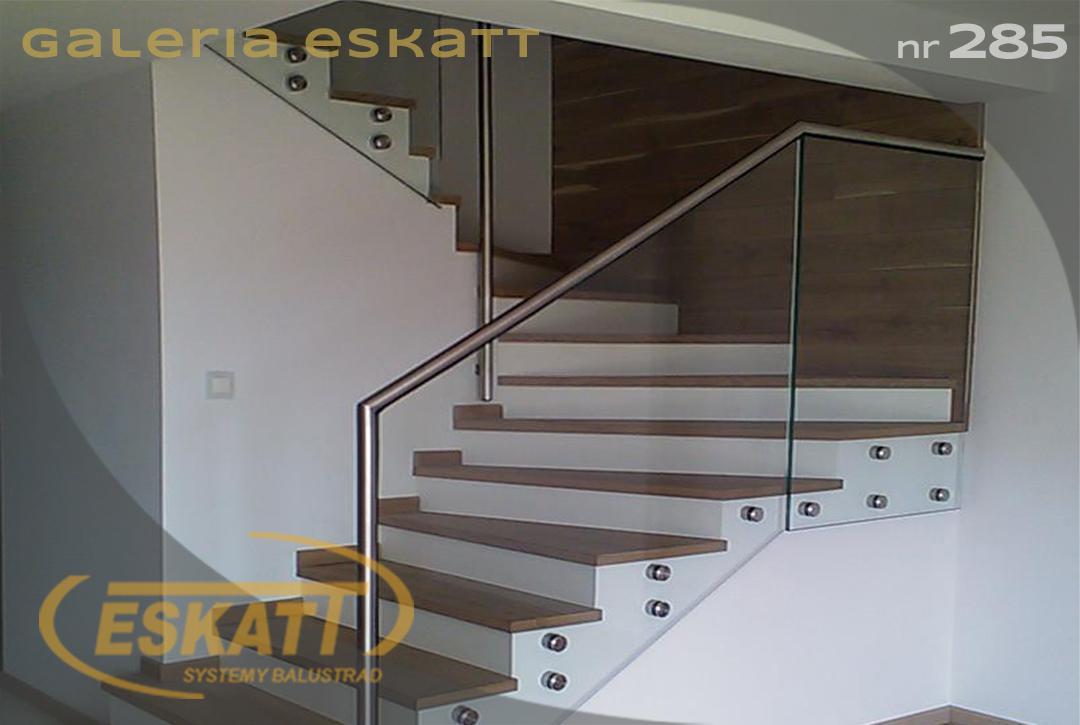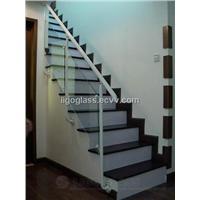The first image is the image on the left, the second image is the image on the right. Considering the images on both sides, is "An image shows a stairwell enclosed by glass panels without a top rail or hinges." valid? Answer yes or no. No. 